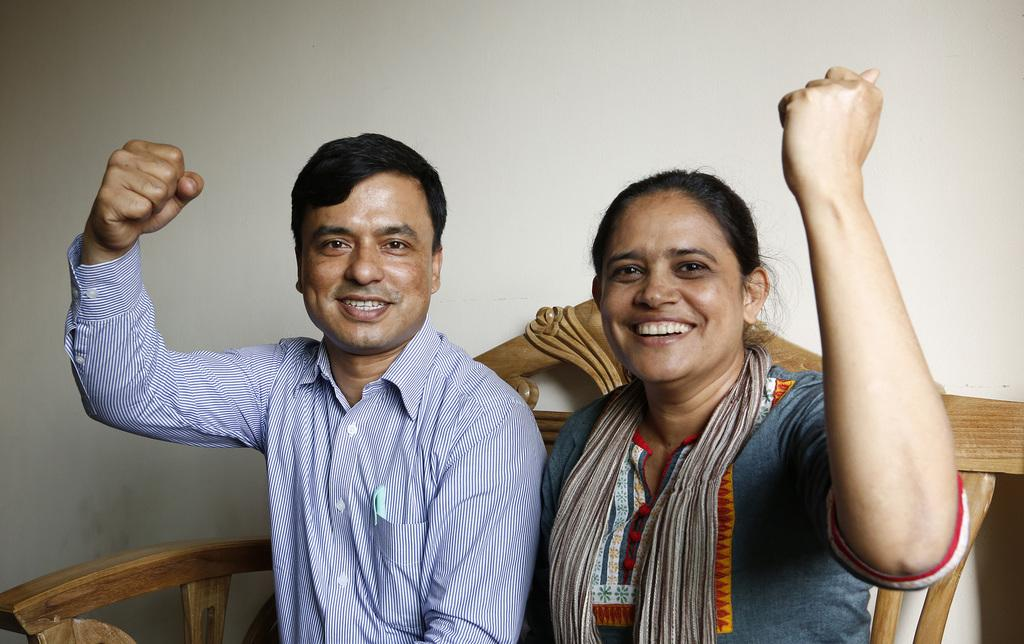Who is present in the image? There is a man and a woman in the image. What expressions do the man and woman have in the image? Both the man and the woman are smiling in the image. What can be seen in the background of the image? There is a wooden object and a wall in the background of the image. What type of marble structure can be seen in the image? There is no marble structure present in the image. Is the image taken in a land of tents? The image does not depict a land of tents; it features a man and a woman smiling in front of a wall and a wooden object. 